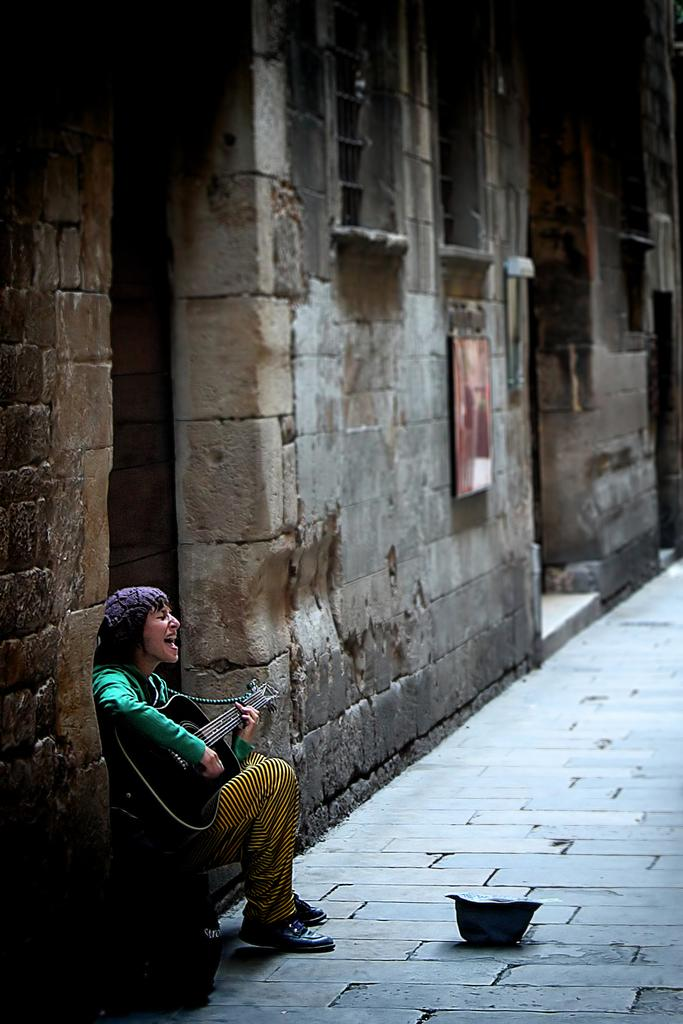What is the person in the image doing? The person is sitting in the image and holding a guitar. What object is the person holding? The person is holding a guitar. What can be seen on the ground in the image? There is a cap on the path in the image. What is visible in the background of the image? There is a building in the background of the image. How does the person in the image pull the bee out of the guitar? There is no bee present in the image, and the person is not pulling anything out of the guitar. 